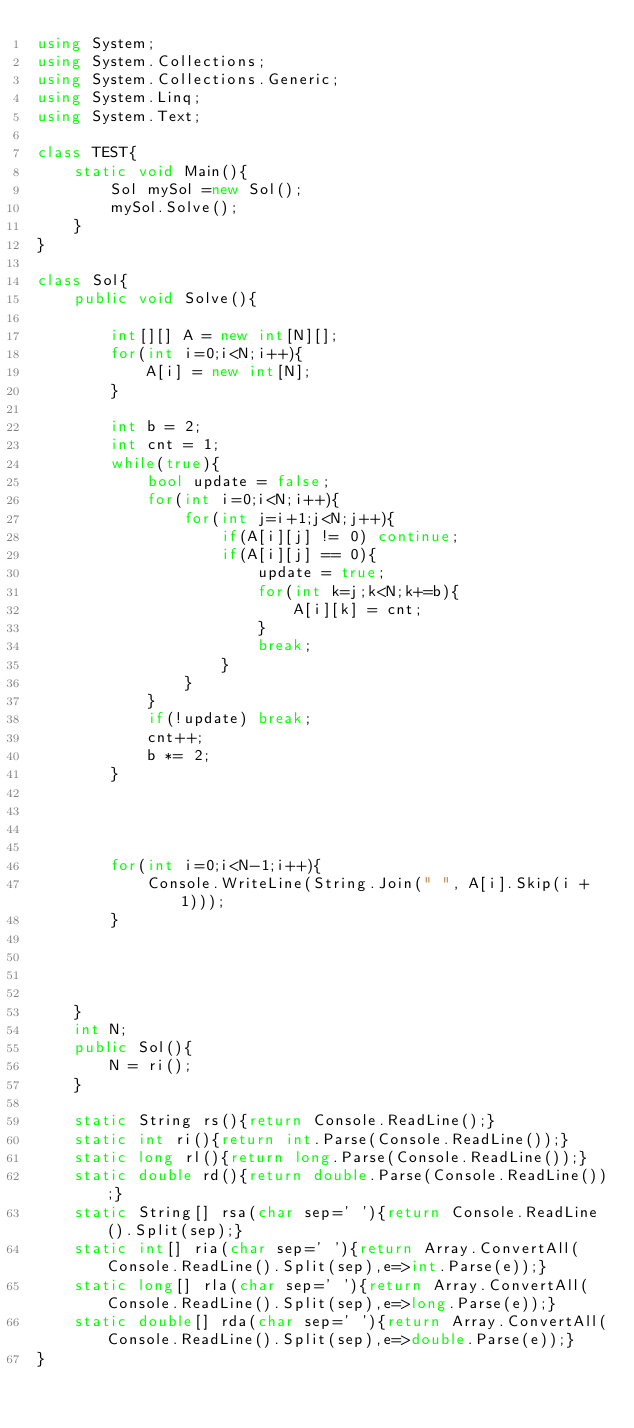<code> <loc_0><loc_0><loc_500><loc_500><_C#_>using System;
using System.Collections;
using System.Collections.Generic;
using System.Linq;
using System.Text;

class TEST{
	static void Main(){
		Sol mySol =new Sol();
		mySol.Solve();
	}
}

class Sol{
	public void Solve(){
		
		int[][] A = new int[N][];
		for(int i=0;i<N;i++){
			A[i] = new int[N];
		}
		
		int b = 2;
		int cnt = 1;
		while(true){
			bool update = false;
			for(int i=0;i<N;i++){
				for(int j=i+1;j<N;j++){
					if(A[i][j] != 0) continue;
					if(A[i][j] == 0){
						update = true;
						for(int k=j;k<N;k+=b){
							A[i][k] = cnt;
						}
						break;
					}
				}
			}
			if(!update) break;
			cnt++;
			b *= 2;
		}
		
		
		
		
		for(int i=0;i<N-1;i++){
			Console.WriteLine(String.Join(" ", A[i].Skip(i + 1)));
		}
		
		
		
		
	}
	int N;
	public Sol(){
		N = ri();
	}

	static String rs(){return Console.ReadLine();}
	static int ri(){return int.Parse(Console.ReadLine());}
	static long rl(){return long.Parse(Console.ReadLine());}
	static double rd(){return double.Parse(Console.ReadLine());}
	static String[] rsa(char sep=' '){return Console.ReadLine().Split(sep);}
	static int[] ria(char sep=' '){return Array.ConvertAll(Console.ReadLine().Split(sep),e=>int.Parse(e));}
	static long[] rla(char sep=' '){return Array.ConvertAll(Console.ReadLine().Split(sep),e=>long.Parse(e));}
	static double[] rda(char sep=' '){return Array.ConvertAll(Console.ReadLine().Split(sep),e=>double.Parse(e));}
}
</code> 